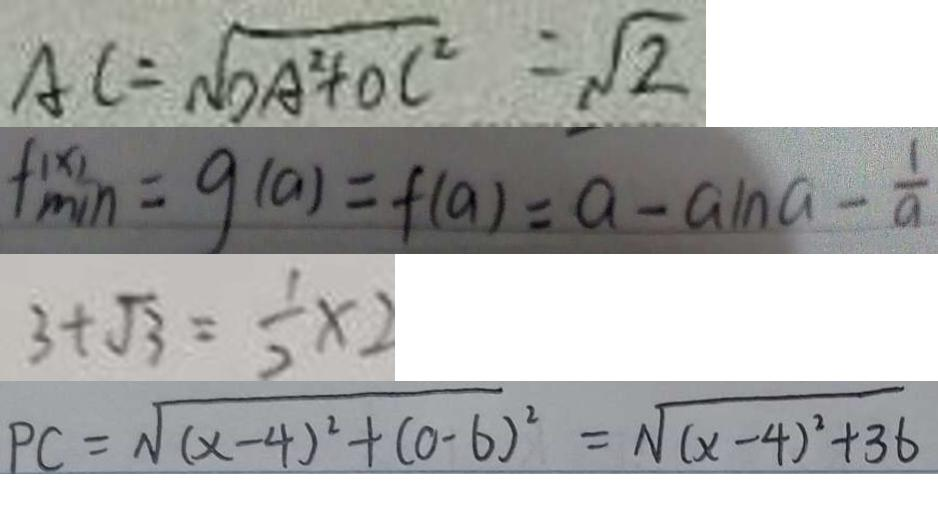<formula> <loc_0><loc_0><loc_500><loc_500>A C = \sqrt { D A ^ { 2 } + O C ^ { 2 } } = \sqrt { 2 } 
 f ^ { ( x ) } _ { \min } = g ( a ) = f ( a ) = a - a \ln a - \frac { 1 } { a } 
 3 + \sqrt { 3 } = \frac { 1 } { 2 } x 
 P C = \sqrt { ( x - 4 ) ^ { 2 } + ( 0 - 6 ) ^ { 2 } } = \sqrt { ( x - 4 ) ^ { 2 } + 3 6 }</formula> 